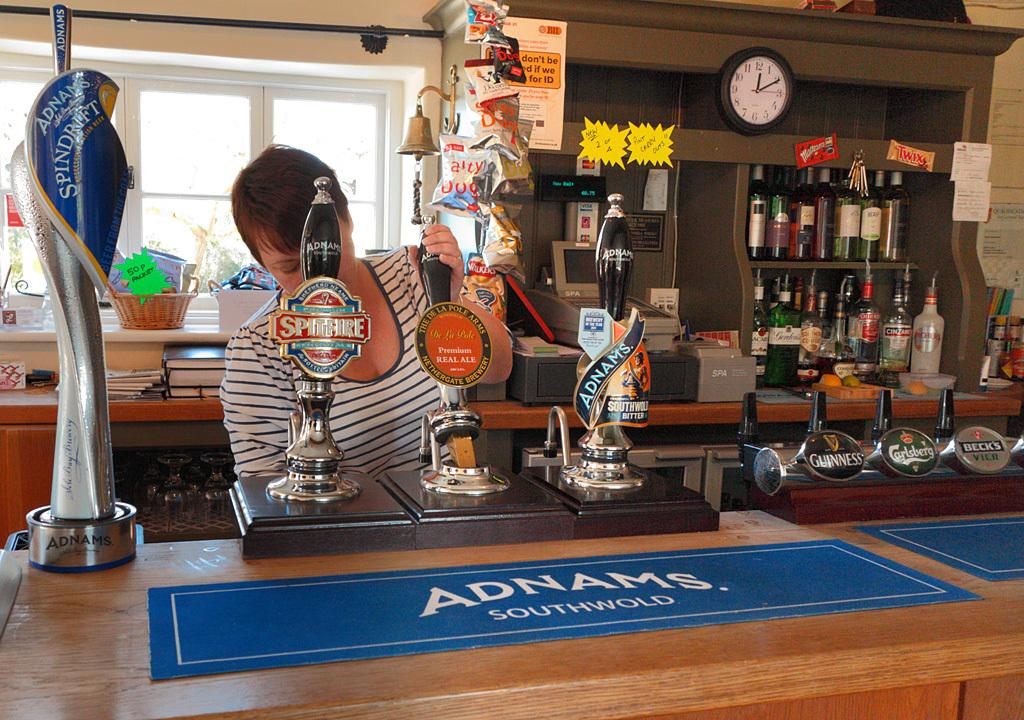Provide a one-sentence caption for the provided image. Adnam's, Guinness, Spitfire, and Carlsberg are among the draft beers available at this bar. 